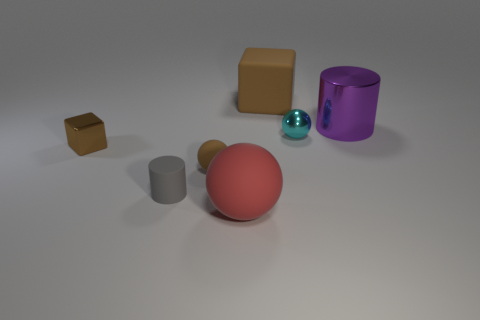Subtract all rubber spheres. How many spheres are left? 1 Add 1 small brown metallic objects. How many objects exist? 8 Subtract all cyan balls. How many balls are left? 2 Subtract 1 balls. How many balls are left? 2 Subtract all spheres. How many objects are left? 4 Subtract 0 green cylinders. How many objects are left? 7 Subtract all purple blocks. Subtract all blue balls. How many blocks are left? 2 Subtract all metallic objects. Subtract all cyan metal balls. How many objects are left? 3 Add 3 rubber objects. How many rubber objects are left? 7 Add 1 tiny red shiny cylinders. How many tiny red shiny cylinders exist? 1 